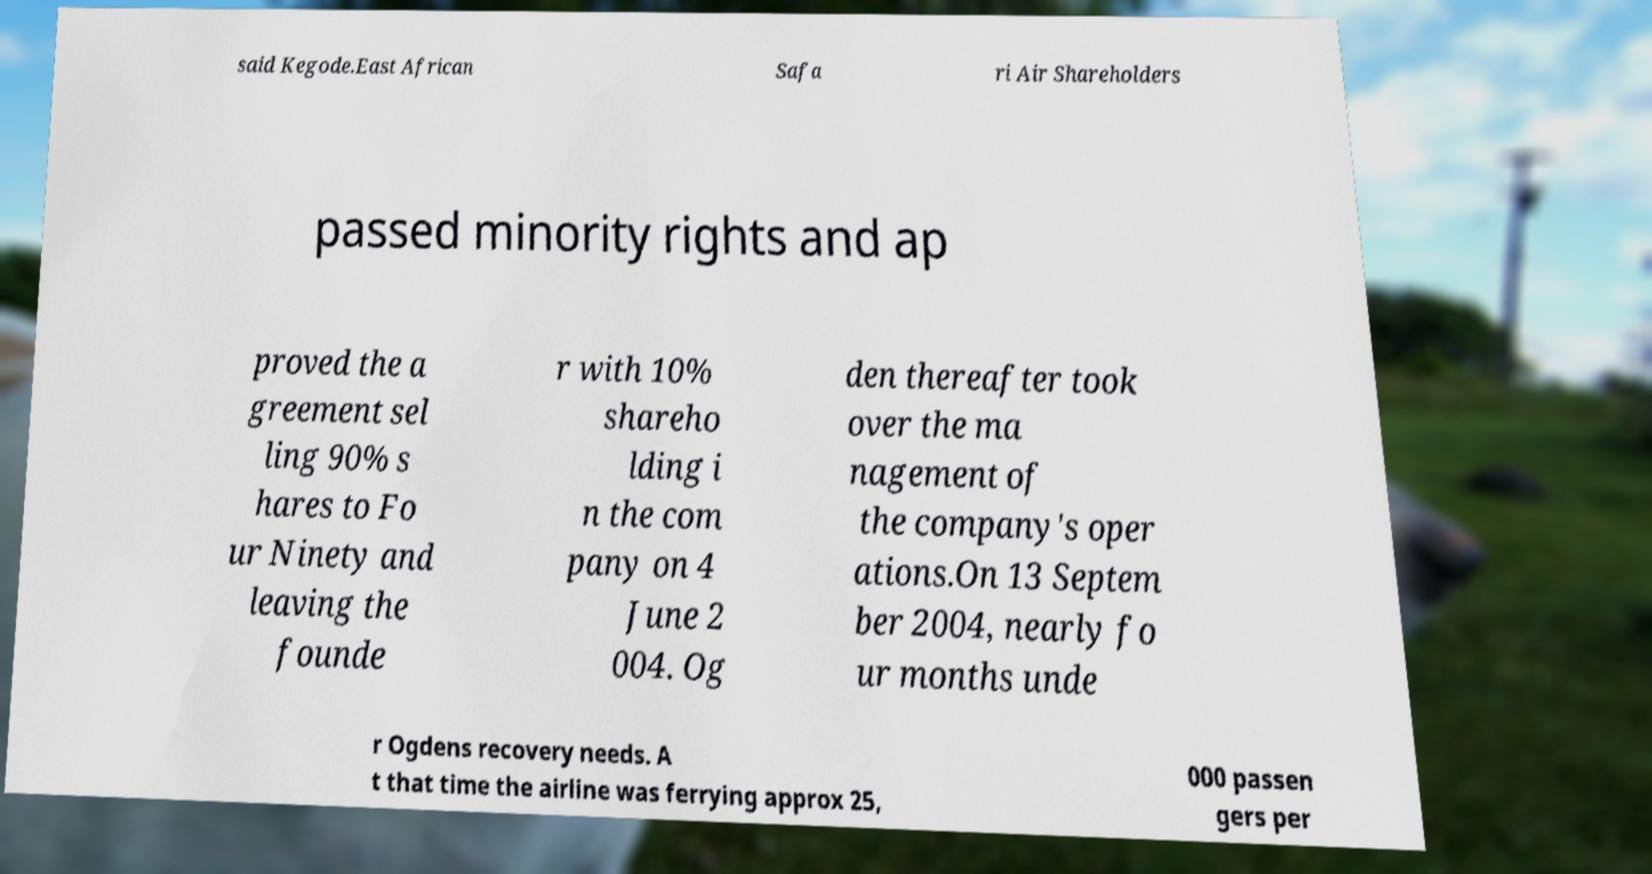Please identify and transcribe the text found in this image. said Kegode.East African Safa ri Air Shareholders passed minority rights and ap proved the a greement sel ling 90% s hares to Fo ur Ninety and leaving the founde r with 10% shareho lding i n the com pany on 4 June 2 004. Og den thereafter took over the ma nagement of the company's oper ations.On 13 Septem ber 2004, nearly fo ur months unde r Ogdens recovery needs. A t that time the airline was ferrying approx 25, 000 passen gers per 